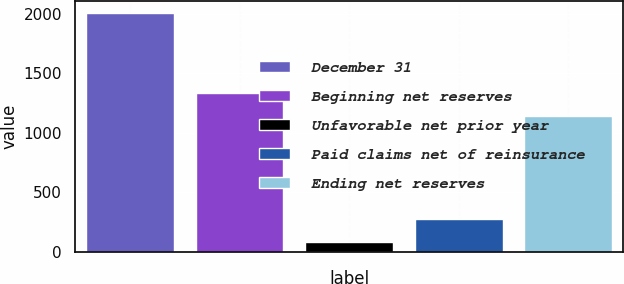<chart> <loc_0><loc_0><loc_500><loc_500><bar_chart><fcel>December 31<fcel>Beginning net reserves<fcel>Unfavorable net prior year<fcel>Paid claims net of reinsurance<fcel>Ending net reserves<nl><fcel>2009<fcel>1330<fcel>79<fcel>272<fcel>1137<nl></chart> 